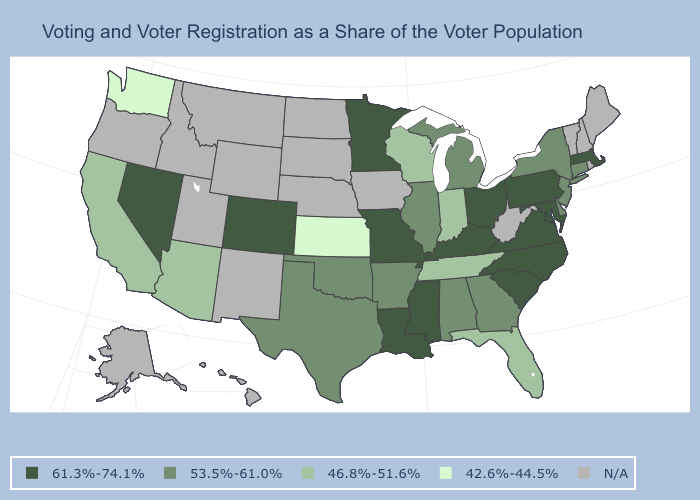Among the states that border New Mexico , which have the lowest value?
Short answer required. Arizona. Among the states that border New Jersey , does Pennsylvania have the highest value?
Write a very short answer. Yes. Does Colorado have the highest value in the West?
Quick response, please. Yes. Which states hav the highest value in the MidWest?
Answer briefly. Minnesota, Missouri, Ohio. Among the states that border Georgia , which have the lowest value?
Short answer required. Florida, Tennessee. What is the value of Virginia?
Quick response, please. 61.3%-74.1%. Does the first symbol in the legend represent the smallest category?
Keep it brief. No. What is the value of North Dakota?
Give a very brief answer. N/A. Name the states that have a value in the range 46.8%-51.6%?
Give a very brief answer. Arizona, California, Florida, Indiana, Tennessee, Wisconsin. Name the states that have a value in the range 61.3%-74.1%?
Give a very brief answer. Colorado, Kentucky, Louisiana, Maryland, Massachusetts, Minnesota, Mississippi, Missouri, Nevada, North Carolina, Ohio, Pennsylvania, South Carolina, Virginia. What is the value of North Dakota?
Give a very brief answer. N/A. Name the states that have a value in the range 61.3%-74.1%?
Concise answer only. Colorado, Kentucky, Louisiana, Maryland, Massachusetts, Minnesota, Mississippi, Missouri, Nevada, North Carolina, Ohio, Pennsylvania, South Carolina, Virginia. What is the value of Georgia?
Give a very brief answer. 53.5%-61.0%. Does the map have missing data?
Answer briefly. Yes. 